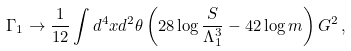Convert formula to latex. <formula><loc_0><loc_0><loc_500><loc_500>\Gamma _ { 1 } \to \frac { 1 } { 1 2 } \int d ^ { 4 } x d ^ { 2 } \theta \left ( 2 8 \log \frac { S } { \Lambda _ { 1 } ^ { 3 } } - 4 2 \log m \right ) G ^ { 2 } \, ,</formula> 